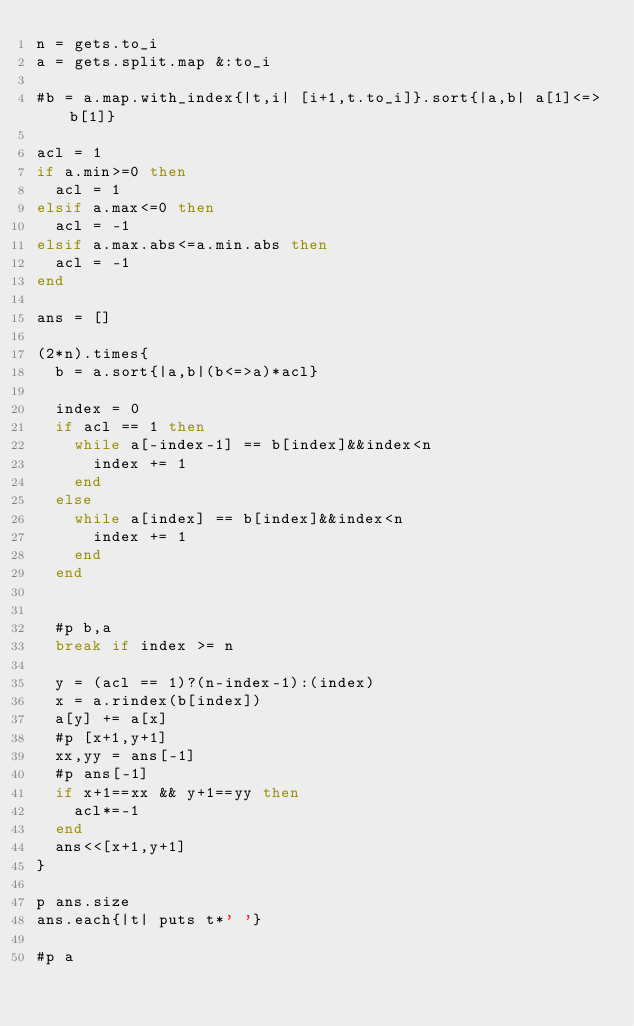Convert code to text. <code><loc_0><loc_0><loc_500><loc_500><_Ruby_>n = gets.to_i
a = gets.split.map &:to_i

#b = a.map.with_index{|t,i| [i+1,t.to_i]}.sort{|a,b| a[1]<=>b[1]}

acl = 1
if a.min>=0 then
  acl = 1
elsif a.max<=0 then
  acl = -1
elsif a.max.abs<=a.min.abs then
  acl = -1
end

ans = []

(2*n).times{
  b = a.sort{|a,b|(b<=>a)*acl}
  
  index = 0
  if acl == 1 then
    while a[-index-1] == b[index]&&index<n
      index += 1
    end
  else
    while a[index] == b[index]&&index<n
      index += 1
    end
  end
  
  
  #p b,a
  break if index >= n
  
  y = (acl == 1)?(n-index-1):(index)
  x = a.rindex(b[index])
  a[y] += a[x]
  #p [x+1,y+1]
  xx,yy = ans[-1]
  #p ans[-1]
  if x+1==xx && y+1==yy then
    acl*=-1
  end
  ans<<[x+1,y+1]
}

p ans.size
ans.each{|t| puts t*' '}

#p a</code> 